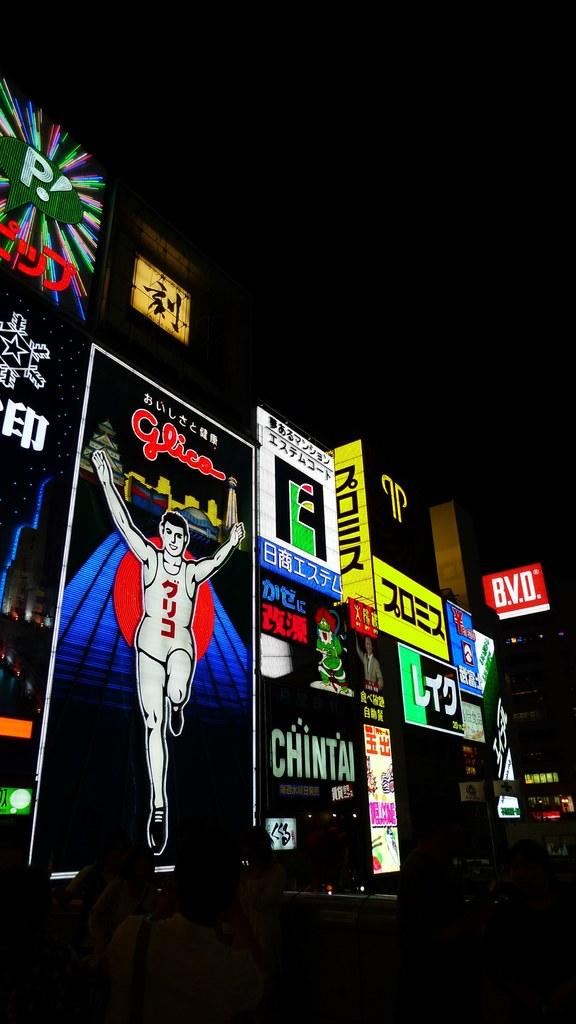<image>
Write a terse but informative summary of the picture. Many brightly lit Japanese advertisements for things like Chintai line the street. 